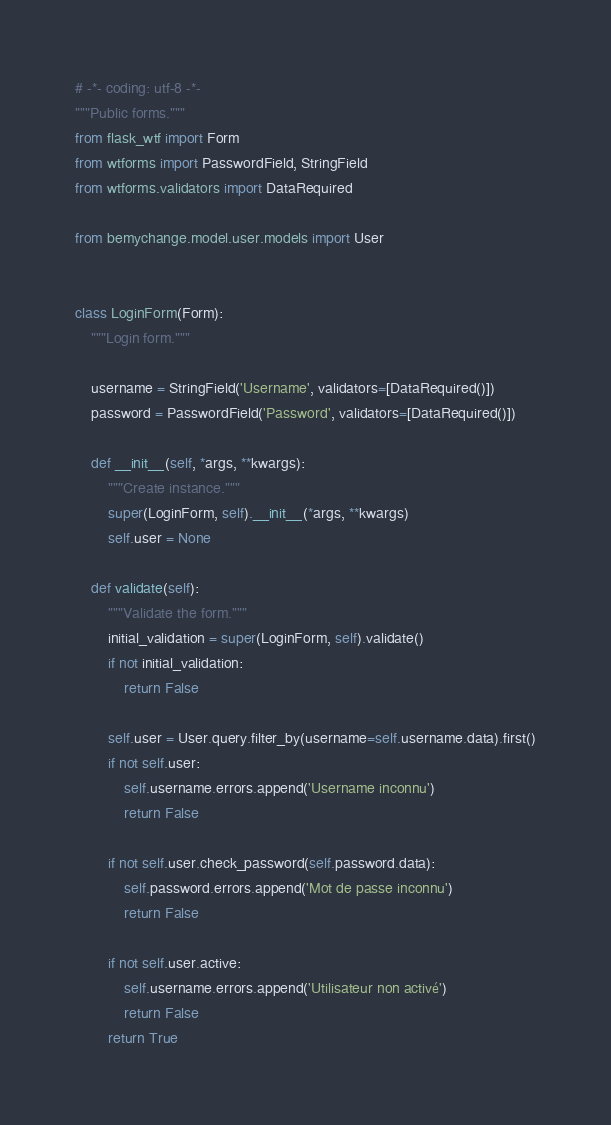Convert code to text. <code><loc_0><loc_0><loc_500><loc_500><_Python_># -*- coding: utf-8 -*-
"""Public forms."""
from flask_wtf import Form
from wtforms import PasswordField, StringField
from wtforms.validators import DataRequired

from bemychange.model.user.models import User


class LoginForm(Form):
    """Login form."""

    username = StringField('Username', validators=[DataRequired()])
    password = PasswordField('Password', validators=[DataRequired()])

    def __init__(self, *args, **kwargs):
        """Create instance."""
        super(LoginForm, self).__init__(*args, **kwargs)
        self.user = None

    def validate(self):
        """Validate the form."""
        initial_validation = super(LoginForm, self).validate()
        if not initial_validation:
            return False

        self.user = User.query.filter_by(username=self.username.data).first()
        if not self.user:
            self.username.errors.append('Username inconnu')
            return False

        if not self.user.check_password(self.password.data):
            self.password.errors.append('Mot de passe inconnu')
            return False

        if not self.user.active:
            self.username.errors.append('Utilisateur non activé')
            return False
        return True
</code> 